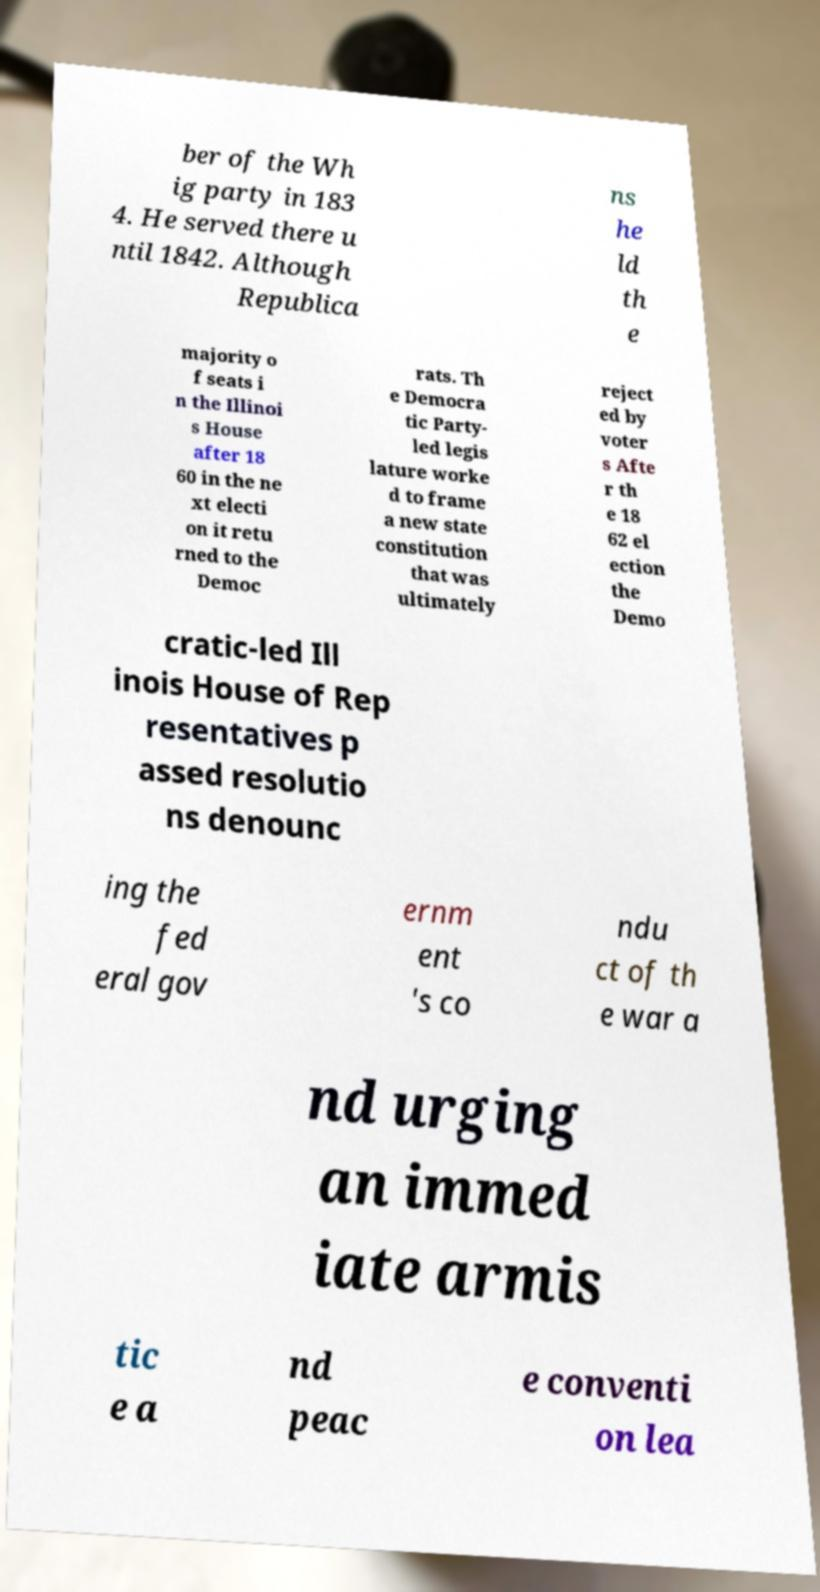Can you accurately transcribe the text from the provided image for me? ber of the Wh ig party in 183 4. He served there u ntil 1842. Although Republica ns he ld th e majority o f seats i n the Illinoi s House after 18 60 in the ne xt electi on it retu rned to the Democ rats. Th e Democra tic Party- led legis lature worke d to frame a new state constitution that was ultimately reject ed by voter s Afte r th e 18 62 el ection the Demo cratic-led Ill inois House of Rep resentatives p assed resolutio ns denounc ing the fed eral gov ernm ent 's co ndu ct of th e war a nd urging an immed iate armis tic e a nd peac e conventi on lea 